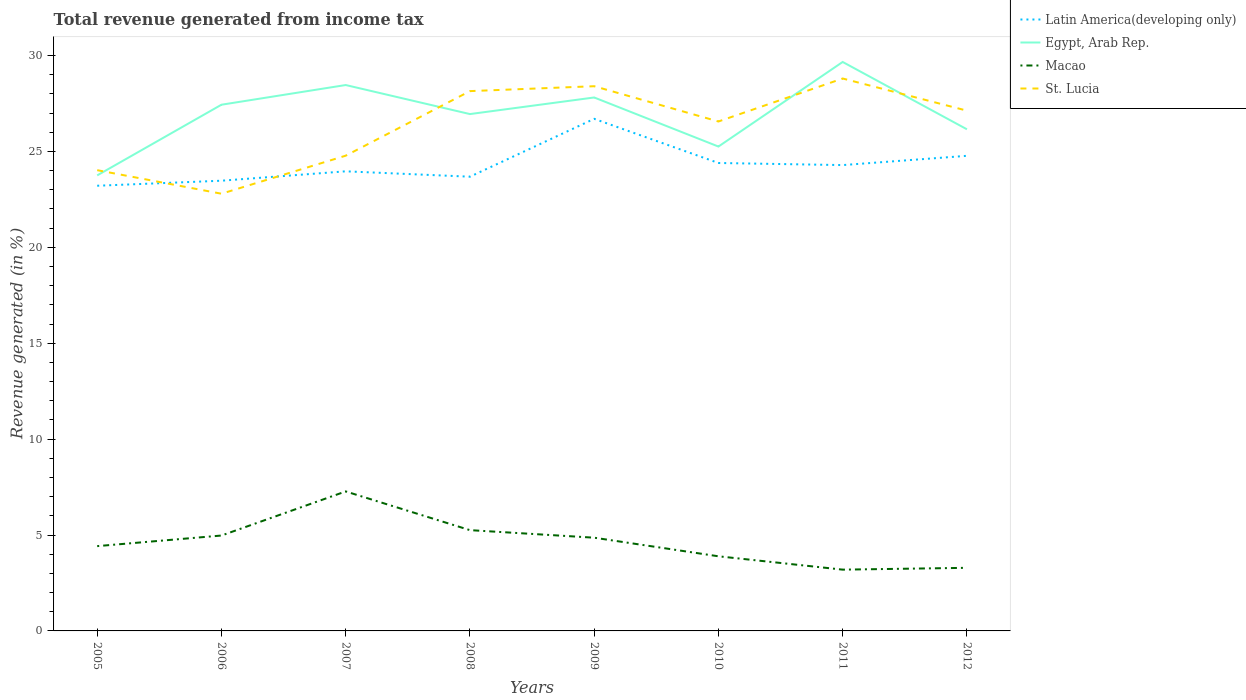How many different coloured lines are there?
Provide a short and direct response. 4. Does the line corresponding to Macao intersect with the line corresponding to Egypt, Arab Rep.?
Offer a very short reply. No. Is the number of lines equal to the number of legend labels?
Your response must be concise. Yes. Across all years, what is the maximum total revenue generated in Egypt, Arab Rep.?
Ensure brevity in your answer.  23.75. What is the total total revenue generated in St. Lucia in the graph?
Provide a short and direct response. 1.02. What is the difference between the highest and the second highest total revenue generated in Latin America(developing only)?
Offer a terse response. 3.49. What is the difference between the highest and the lowest total revenue generated in Latin America(developing only)?
Make the answer very short. 3. What is the difference between two consecutive major ticks on the Y-axis?
Ensure brevity in your answer.  5. Are the values on the major ticks of Y-axis written in scientific E-notation?
Make the answer very short. No. Does the graph contain any zero values?
Your answer should be very brief. No. How are the legend labels stacked?
Your response must be concise. Vertical. What is the title of the graph?
Offer a very short reply. Total revenue generated from income tax. What is the label or title of the Y-axis?
Your response must be concise. Revenue generated (in %). What is the Revenue generated (in %) in Latin America(developing only) in 2005?
Give a very brief answer. 23.21. What is the Revenue generated (in %) of Egypt, Arab Rep. in 2005?
Ensure brevity in your answer.  23.75. What is the Revenue generated (in %) in Macao in 2005?
Offer a very short reply. 4.42. What is the Revenue generated (in %) of St. Lucia in 2005?
Your answer should be very brief. 24.02. What is the Revenue generated (in %) of Latin America(developing only) in 2006?
Your answer should be very brief. 23.47. What is the Revenue generated (in %) in Egypt, Arab Rep. in 2006?
Offer a terse response. 27.44. What is the Revenue generated (in %) in Macao in 2006?
Your answer should be very brief. 4.97. What is the Revenue generated (in %) of St. Lucia in 2006?
Offer a very short reply. 22.8. What is the Revenue generated (in %) in Latin America(developing only) in 2007?
Your response must be concise. 23.96. What is the Revenue generated (in %) of Egypt, Arab Rep. in 2007?
Offer a terse response. 28.46. What is the Revenue generated (in %) in Macao in 2007?
Provide a succinct answer. 7.27. What is the Revenue generated (in %) of St. Lucia in 2007?
Give a very brief answer. 24.78. What is the Revenue generated (in %) in Latin America(developing only) in 2008?
Offer a terse response. 23.68. What is the Revenue generated (in %) in Egypt, Arab Rep. in 2008?
Keep it short and to the point. 26.95. What is the Revenue generated (in %) of Macao in 2008?
Make the answer very short. 5.25. What is the Revenue generated (in %) of St. Lucia in 2008?
Offer a terse response. 28.15. What is the Revenue generated (in %) of Latin America(developing only) in 2009?
Keep it short and to the point. 26.7. What is the Revenue generated (in %) of Egypt, Arab Rep. in 2009?
Offer a very short reply. 27.81. What is the Revenue generated (in %) in Macao in 2009?
Your answer should be compact. 4.86. What is the Revenue generated (in %) in St. Lucia in 2009?
Your answer should be very brief. 28.4. What is the Revenue generated (in %) of Latin America(developing only) in 2010?
Make the answer very short. 24.4. What is the Revenue generated (in %) in Egypt, Arab Rep. in 2010?
Provide a succinct answer. 25.26. What is the Revenue generated (in %) in Macao in 2010?
Make the answer very short. 3.89. What is the Revenue generated (in %) in St. Lucia in 2010?
Make the answer very short. 26.56. What is the Revenue generated (in %) in Latin America(developing only) in 2011?
Give a very brief answer. 24.29. What is the Revenue generated (in %) of Egypt, Arab Rep. in 2011?
Your answer should be very brief. 29.67. What is the Revenue generated (in %) of Macao in 2011?
Offer a terse response. 3.2. What is the Revenue generated (in %) in St. Lucia in 2011?
Ensure brevity in your answer.  28.8. What is the Revenue generated (in %) in Latin America(developing only) in 2012?
Your answer should be very brief. 24.77. What is the Revenue generated (in %) of Egypt, Arab Rep. in 2012?
Your response must be concise. 26.15. What is the Revenue generated (in %) of Macao in 2012?
Make the answer very short. 3.29. What is the Revenue generated (in %) in St. Lucia in 2012?
Your answer should be very brief. 27.13. Across all years, what is the maximum Revenue generated (in %) of Latin America(developing only)?
Give a very brief answer. 26.7. Across all years, what is the maximum Revenue generated (in %) of Egypt, Arab Rep.?
Offer a terse response. 29.67. Across all years, what is the maximum Revenue generated (in %) in Macao?
Your response must be concise. 7.27. Across all years, what is the maximum Revenue generated (in %) in St. Lucia?
Keep it short and to the point. 28.8. Across all years, what is the minimum Revenue generated (in %) in Latin America(developing only)?
Ensure brevity in your answer.  23.21. Across all years, what is the minimum Revenue generated (in %) of Egypt, Arab Rep.?
Your response must be concise. 23.75. Across all years, what is the minimum Revenue generated (in %) of Macao?
Your answer should be compact. 3.2. Across all years, what is the minimum Revenue generated (in %) in St. Lucia?
Keep it short and to the point. 22.8. What is the total Revenue generated (in %) of Latin America(developing only) in the graph?
Provide a succinct answer. 194.49. What is the total Revenue generated (in %) of Egypt, Arab Rep. in the graph?
Offer a terse response. 215.49. What is the total Revenue generated (in %) of Macao in the graph?
Keep it short and to the point. 37.16. What is the total Revenue generated (in %) of St. Lucia in the graph?
Your response must be concise. 210.64. What is the difference between the Revenue generated (in %) in Latin America(developing only) in 2005 and that in 2006?
Your answer should be compact. -0.26. What is the difference between the Revenue generated (in %) in Egypt, Arab Rep. in 2005 and that in 2006?
Your answer should be very brief. -3.68. What is the difference between the Revenue generated (in %) of Macao in 2005 and that in 2006?
Your response must be concise. -0.55. What is the difference between the Revenue generated (in %) of St. Lucia in 2005 and that in 2006?
Provide a succinct answer. 1.23. What is the difference between the Revenue generated (in %) in Latin America(developing only) in 2005 and that in 2007?
Provide a succinct answer. -0.75. What is the difference between the Revenue generated (in %) of Egypt, Arab Rep. in 2005 and that in 2007?
Offer a terse response. -4.71. What is the difference between the Revenue generated (in %) of Macao in 2005 and that in 2007?
Keep it short and to the point. -2.85. What is the difference between the Revenue generated (in %) in St. Lucia in 2005 and that in 2007?
Give a very brief answer. -0.76. What is the difference between the Revenue generated (in %) in Latin America(developing only) in 2005 and that in 2008?
Your answer should be very brief. -0.47. What is the difference between the Revenue generated (in %) of Egypt, Arab Rep. in 2005 and that in 2008?
Your answer should be compact. -3.2. What is the difference between the Revenue generated (in %) of Macao in 2005 and that in 2008?
Provide a short and direct response. -0.83. What is the difference between the Revenue generated (in %) in St. Lucia in 2005 and that in 2008?
Offer a terse response. -4.12. What is the difference between the Revenue generated (in %) of Latin America(developing only) in 2005 and that in 2009?
Offer a very short reply. -3.49. What is the difference between the Revenue generated (in %) in Egypt, Arab Rep. in 2005 and that in 2009?
Your answer should be very brief. -4.06. What is the difference between the Revenue generated (in %) in Macao in 2005 and that in 2009?
Give a very brief answer. -0.44. What is the difference between the Revenue generated (in %) in St. Lucia in 2005 and that in 2009?
Keep it short and to the point. -4.38. What is the difference between the Revenue generated (in %) in Latin America(developing only) in 2005 and that in 2010?
Give a very brief answer. -1.19. What is the difference between the Revenue generated (in %) of Egypt, Arab Rep. in 2005 and that in 2010?
Ensure brevity in your answer.  -1.5. What is the difference between the Revenue generated (in %) of Macao in 2005 and that in 2010?
Provide a short and direct response. 0.53. What is the difference between the Revenue generated (in %) in St. Lucia in 2005 and that in 2010?
Your response must be concise. -2.54. What is the difference between the Revenue generated (in %) of Latin America(developing only) in 2005 and that in 2011?
Your answer should be very brief. -1.08. What is the difference between the Revenue generated (in %) of Egypt, Arab Rep. in 2005 and that in 2011?
Keep it short and to the point. -5.91. What is the difference between the Revenue generated (in %) in Macao in 2005 and that in 2011?
Your answer should be compact. 1.23. What is the difference between the Revenue generated (in %) of St. Lucia in 2005 and that in 2011?
Provide a succinct answer. -4.78. What is the difference between the Revenue generated (in %) of Latin America(developing only) in 2005 and that in 2012?
Offer a very short reply. -1.56. What is the difference between the Revenue generated (in %) in Egypt, Arab Rep. in 2005 and that in 2012?
Your answer should be compact. -2.4. What is the difference between the Revenue generated (in %) of Macao in 2005 and that in 2012?
Your answer should be compact. 1.13. What is the difference between the Revenue generated (in %) of St. Lucia in 2005 and that in 2012?
Your answer should be compact. -3.1. What is the difference between the Revenue generated (in %) of Latin America(developing only) in 2006 and that in 2007?
Provide a succinct answer. -0.49. What is the difference between the Revenue generated (in %) in Egypt, Arab Rep. in 2006 and that in 2007?
Make the answer very short. -1.03. What is the difference between the Revenue generated (in %) in Macao in 2006 and that in 2007?
Ensure brevity in your answer.  -2.3. What is the difference between the Revenue generated (in %) of St. Lucia in 2006 and that in 2007?
Make the answer very short. -1.98. What is the difference between the Revenue generated (in %) of Latin America(developing only) in 2006 and that in 2008?
Offer a terse response. -0.21. What is the difference between the Revenue generated (in %) of Egypt, Arab Rep. in 2006 and that in 2008?
Your answer should be compact. 0.49. What is the difference between the Revenue generated (in %) in Macao in 2006 and that in 2008?
Ensure brevity in your answer.  -0.28. What is the difference between the Revenue generated (in %) of St. Lucia in 2006 and that in 2008?
Provide a short and direct response. -5.35. What is the difference between the Revenue generated (in %) of Latin America(developing only) in 2006 and that in 2009?
Keep it short and to the point. -3.23. What is the difference between the Revenue generated (in %) in Egypt, Arab Rep. in 2006 and that in 2009?
Make the answer very short. -0.38. What is the difference between the Revenue generated (in %) in Macao in 2006 and that in 2009?
Provide a succinct answer. 0.11. What is the difference between the Revenue generated (in %) in St. Lucia in 2006 and that in 2009?
Offer a terse response. -5.61. What is the difference between the Revenue generated (in %) of Latin America(developing only) in 2006 and that in 2010?
Your answer should be very brief. -0.92. What is the difference between the Revenue generated (in %) of Egypt, Arab Rep. in 2006 and that in 2010?
Ensure brevity in your answer.  2.18. What is the difference between the Revenue generated (in %) of Macao in 2006 and that in 2010?
Offer a terse response. 1.08. What is the difference between the Revenue generated (in %) of St. Lucia in 2006 and that in 2010?
Ensure brevity in your answer.  -3.77. What is the difference between the Revenue generated (in %) in Latin America(developing only) in 2006 and that in 2011?
Provide a succinct answer. -0.81. What is the difference between the Revenue generated (in %) of Egypt, Arab Rep. in 2006 and that in 2011?
Provide a short and direct response. -2.23. What is the difference between the Revenue generated (in %) in Macao in 2006 and that in 2011?
Offer a terse response. 1.78. What is the difference between the Revenue generated (in %) of St. Lucia in 2006 and that in 2011?
Make the answer very short. -6.01. What is the difference between the Revenue generated (in %) in Latin America(developing only) in 2006 and that in 2012?
Provide a short and direct response. -1.3. What is the difference between the Revenue generated (in %) in Egypt, Arab Rep. in 2006 and that in 2012?
Provide a short and direct response. 1.28. What is the difference between the Revenue generated (in %) in Macao in 2006 and that in 2012?
Your answer should be compact. 1.68. What is the difference between the Revenue generated (in %) of St. Lucia in 2006 and that in 2012?
Provide a short and direct response. -4.33. What is the difference between the Revenue generated (in %) of Latin America(developing only) in 2007 and that in 2008?
Offer a very short reply. 0.28. What is the difference between the Revenue generated (in %) of Egypt, Arab Rep. in 2007 and that in 2008?
Ensure brevity in your answer.  1.51. What is the difference between the Revenue generated (in %) of Macao in 2007 and that in 2008?
Provide a short and direct response. 2.02. What is the difference between the Revenue generated (in %) in St. Lucia in 2007 and that in 2008?
Your answer should be compact. -3.37. What is the difference between the Revenue generated (in %) of Latin America(developing only) in 2007 and that in 2009?
Provide a short and direct response. -2.74. What is the difference between the Revenue generated (in %) of Egypt, Arab Rep. in 2007 and that in 2009?
Provide a succinct answer. 0.65. What is the difference between the Revenue generated (in %) of Macao in 2007 and that in 2009?
Provide a short and direct response. 2.41. What is the difference between the Revenue generated (in %) in St. Lucia in 2007 and that in 2009?
Offer a very short reply. -3.62. What is the difference between the Revenue generated (in %) in Latin America(developing only) in 2007 and that in 2010?
Your answer should be compact. -0.43. What is the difference between the Revenue generated (in %) of Egypt, Arab Rep. in 2007 and that in 2010?
Make the answer very short. 3.21. What is the difference between the Revenue generated (in %) of Macao in 2007 and that in 2010?
Your response must be concise. 3.38. What is the difference between the Revenue generated (in %) of St. Lucia in 2007 and that in 2010?
Your answer should be compact. -1.78. What is the difference between the Revenue generated (in %) of Latin America(developing only) in 2007 and that in 2011?
Keep it short and to the point. -0.33. What is the difference between the Revenue generated (in %) in Egypt, Arab Rep. in 2007 and that in 2011?
Your response must be concise. -1.2. What is the difference between the Revenue generated (in %) in Macao in 2007 and that in 2011?
Your response must be concise. 4.08. What is the difference between the Revenue generated (in %) of St. Lucia in 2007 and that in 2011?
Offer a very short reply. -4.02. What is the difference between the Revenue generated (in %) of Latin America(developing only) in 2007 and that in 2012?
Give a very brief answer. -0.81. What is the difference between the Revenue generated (in %) in Egypt, Arab Rep. in 2007 and that in 2012?
Make the answer very short. 2.31. What is the difference between the Revenue generated (in %) in Macao in 2007 and that in 2012?
Offer a very short reply. 3.98. What is the difference between the Revenue generated (in %) in St. Lucia in 2007 and that in 2012?
Offer a very short reply. -2.35. What is the difference between the Revenue generated (in %) of Latin America(developing only) in 2008 and that in 2009?
Your response must be concise. -3.02. What is the difference between the Revenue generated (in %) of Egypt, Arab Rep. in 2008 and that in 2009?
Your response must be concise. -0.86. What is the difference between the Revenue generated (in %) in Macao in 2008 and that in 2009?
Provide a short and direct response. 0.39. What is the difference between the Revenue generated (in %) of St. Lucia in 2008 and that in 2009?
Offer a terse response. -0.26. What is the difference between the Revenue generated (in %) in Latin America(developing only) in 2008 and that in 2010?
Your response must be concise. -0.72. What is the difference between the Revenue generated (in %) of Egypt, Arab Rep. in 2008 and that in 2010?
Keep it short and to the point. 1.69. What is the difference between the Revenue generated (in %) of Macao in 2008 and that in 2010?
Keep it short and to the point. 1.36. What is the difference between the Revenue generated (in %) in St. Lucia in 2008 and that in 2010?
Make the answer very short. 1.58. What is the difference between the Revenue generated (in %) of Latin America(developing only) in 2008 and that in 2011?
Keep it short and to the point. -0.61. What is the difference between the Revenue generated (in %) of Egypt, Arab Rep. in 2008 and that in 2011?
Make the answer very short. -2.72. What is the difference between the Revenue generated (in %) in Macao in 2008 and that in 2011?
Offer a terse response. 2.06. What is the difference between the Revenue generated (in %) in St. Lucia in 2008 and that in 2011?
Make the answer very short. -0.66. What is the difference between the Revenue generated (in %) of Latin America(developing only) in 2008 and that in 2012?
Give a very brief answer. -1.09. What is the difference between the Revenue generated (in %) in Egypt, Arab Rep. in 2008 and that in 2012?
Make the answer very short. 0.79. What is the difference between the Revenue generated (in %) in Macao in 2008 and that in 2012?
Your answer should be compact. 1.96. What is the difference between the Revenue generated (in %) of St. Lucia in 2008 and that in 2012?
Keep it short and to the point. 1.02. What is the difference between the Revenue generated (in %) of Latin America(developing only) in 2009 and that in 2010?
Make the answer very short. 2.3. What is the difference between the Revenue generated (in %) in Egypt, Arab Rep. in 2009 and that in 2010?
Provide a short and direct response. 2.56. What is the difference between the Revenue generated (in %) in Macao in 2009 and that in 2010?
Ensure brevity in your answer.  0.97. What is the difference between the Revenue generated (in %) in St. Lucia in 2009 and that in 2010?
Your response must be concise. 1.84. What is the difference between the Revenue generated (in %) in Latin America(developing only) in 2009 and that in 2011?
Provide a succinct answer. 2.41. What is the difference between the Revenue generated (in %) in Egypt, Arab Rep. in 2009 and that in 2011?
Keep it short and to the point. -1.85. What is the difference between the Revenue generated (in %) of Macao in 2009 and that in 2011?
Make the answer very short. 1.67. What is the difference between the Revenue generated (in %) of St. Lucia in 2009 and that in 2011?
Offer a very short reply. -0.4. What is the difference between the Revenue generated (in %) in Latin America(developing only) in 2009 and that in 2012?
Ensure brevity in your answer.  1.93. What is the difference between the Revenue generated (in %) of Egypt, Arab Rep. in 2009 and that in 2012?
Offer a very short reply. 1.66. What is the difference between the Revenue generated (in %) in Macao in 2009 and that in 2012?
Offer a very short reply. 1.57. What is the difference between the Revenue generated (in %) in St. Lucia in 2009 and that in 2012?
Your response must be concise. 1.27. What is the difference between the Revenue generated (in %) in Latin America(developing only) in 2010 and that in 2011?
Give a very brief answer. 0.11. What is the difference between the Revenue generated (in %) of Egypt, Arab Rep. in 2010 and that in 2011?
Make the answer very short. -4.41. What is the difference between the Revenue generated (in %) in Macao in 2010 and that in 2011?
Offer a terse response. 0.7. What is the difference between the Revenue generated (in %) in St. Lucia in 2010 and that in 2011?
Offer a very short reply. -2.24. What is the difference between the Revenue generated (in %) of Latin America(developing only) in 2010 and that in 2012?
Make the answer very short. -0.37. What is the difference between the Revenue generated (in %) of Egypt, Arab Rep. in 2010 and that in 2012?
Give a very brief answer. -0.9. What is the difference between the Revenue generated (in %) of Macao in 2010 and that in 2012?
Your answer should be very brief. 0.6. What is the difference between the Revenue generated (in %) in St. Lucia in 2010 and that in 2012?
Make the answer very short. -0.56. What is the difference between the Revenue generated (in %) in Latin America(developing only) in 2011 and that in 2012?
Give a very brief answer. -0.48. What is the difference between the Revenue generated (in %) in Egypt, Arab Rep. in 2011 and that in 2012?
Provide a short and direct response. 3.51. What is the difference between the Revenue generated (in %) of Macao in 2011 and that in 2012?
Provide a succinct answer. -0.09. What is the difference between the Revenue generated (in %) of St. Lucia in 2011 and that in 2012?
Make the answer very short. 1.68. What is the difference between the Revenue generated (in %) of Latin America(developing only) in 2005 and the Revenue generated (in %) of Egypt, Arab Rep. in 2006?
Give a very brief answer. -4.22. What is the difference between the Revenue generated (in %) in Latin America(developing only) in 2005 and the Revenue generated (in %) in Macao in 2006?
Offer a terse response. 18.24. What is the difference between the Revenue generated (in %) of Latin America(developing only) in 2005 and the Revenue generated (in %) of St. Lucia in 2006?
Your response must be concise. 0.42. What is the difference between the Revenue generated (in %) in Egypt, Arab Rep. in 2005 and the Revenue generated (in %) in Macao in 2006?
Make the answer very short. 18.78. What is the difference between the Revenue generated (in %) in Egypt, Arab Rep. in 2005 and the Revenue generated (in %) in St. Lucia in 2006?
Make the answer very short. 0.96. What is the difference between the Revenue generated (in %) of Macao in 2005 and the Revenue generated (in %) of St. Lucia in 2006?
Your answer should be very brief. -18.37. What is the difference between the Revenue generated (in %) in Latin America(developing only) in 2005 and the Revenue generated (in %) in Egypt, Arab Rep. in 2007?
Your answer should be compact. -5.25. What is the difference between the Revenue generated (in %) of Latin America(developing only) in 2005 and the Revenue generated (in %) of Macao in 2007?
Your answer should be compact. 15.94. What is the difference between the Revenue generated (in %) in Latin America(developing only) in 2005 and the Revenue generated (in %) in St. Lucia in 2007?
Give a very brief answer. -1.57. What is the difference between the Revenue generated (in %) of Egypt, Arab Rep. in 2005 and the Revenue generated (in %) of Macao in 2007?
Provide a succinct answer. 16.48. What is the difference between the Revenue generated (in %) of Egypt, Arab Rep. in 2005 and the Revenue generated (in %) of St. Lucia in 2007?
Provide a succinct answer. -1.03. What is the difference between the Revenue generated (in %) of Macao in 2005 and the Revenue generated (in %) of St. Lucia in 2007?
Keep it short and to the point. -20.36. What is the difference between the Revenue generated (in %) of Latin America(developing only) in 2005 and the Revenue generated (in %) of Egypt, Arab Rep. in 2008?
Give a very brief answer. -3.74. What is the difference between the Revenue generated (in %) of Latin America(developing only) in 2005 and the Revenue generated (in %) of Macao in 2008?
Your answer should be very brief. 17.96. What is the difference between the Revenue generated (in %) in Latin America(developing only) in 2005 and the Revenue generated (in %) in St. Lucia in 2008?
Ensure brevity in your answer.  -4.93. What is the difference between the Revenue generated (in %) in Egypt, Arab Rep. in 2005 and the Revenue generated (in %) in Macao in 2008?
Ensure brevity in your answer.  18.5. What is the difference between the Revenue generated (in %) in Egypt, Arab Rep. in 2005 and the Revenue generated (in %) in St. Lucia in 2008?
Offer a very short reply. -4.39. What is the difference between the Revenue generated (in %) in Macao in 2005 and the Revenue generated (in %) in St. Lucia in 2008?
Ensure brevity in your answer.  -23.72. What is the difference between the Revenue generated (in %) of Latin America(developing only) in 2005 and the Revenue generated (in %) of Egypt, Arab Rep. in 2009?
Provide a short and direct response. -4.6. What is the difference between the Revenue generated (in %) in Latin America(developing only) in 2005 and the Revenue generated (in %) in Macao in 2009?
Give a very brief answer. 18.35. What is the difference between the Revenue generated (in %) in Latin America(developing only) in 2005 and the Revenue generated (in %) in St. Lucia in 2009?
Provide a succinct answer. -5.19. What is the difference between the Revenue generated (in %) in Egypt, Arab Rep. in 2005 and the Revenue generated (in %) in Macao in 2009?
Provide a succinct answer. 18.89. What is the difference between the Revenue generated (in %) of Egypt, Arab Rep. in 2005 and the Revenue generated (in %) of St. Lucia in 2009?
Provide a short and direct response. -4.65. What is the difference between the Revenue generated (in %) of Macao in 2005 and the Revenue generated (in %) of St. Lucia in 2009?
Your response must be concise. -23.98. What is the difference between the Revenue generated (in %) of Latin America(developing only) in 2005 and the Revenue generated (in %) of Egypt, Arab Rep. in 2010?
Offer a terse response. -2.04. What is the difference between the Revenue generated (in %) in Latin America(developing only) in 2005 and the Revenue generated (in %) in Macao in 2010?
Keep it short and to the point. 19.32. What is the difference between the Revenue generated (in %) of Latin America(developing only) in 2005 and the Revenue generated (in %) of St. Lucia in 2010?
Provide a succinct answer. -3.35. What is the difference between the Revenue generated (in %) in Egypt, Arab Rep. in 2005 and the Revenue generated (in %) in Macao in 2010?
Make the answer very short. 19.86. What is the difference between the Revenue generated (in %) in Egypt, Arab Rep. in 2005 and the Revenue generated (in %) in St. Lucia in 2010?
Ensure brevity in your answer.  -2.81. What is the difference between the Revenue generated (in %) in Macao in 2005 and the Revenue generated (in %) in St. Lucia in 2010?
Your response must be concise. -22.14. What is the difference between the Revenue generated (in %) of Latin America(developing only) in 2005 and the Revenue generated (in %) of Egypt, Arab Rep. in 2011?
Your answer should be compact. -6.45. What is the difference between the Revenue generated (in %) of Latin America(developing only) in 2005 and the Revenue generated (in %) of Macao in 2011?
Provide a short and direct response. 20.02. What is the difference between the Revenue generated (in %) of Latin America(developing only) in 2005 and the Revenue generated (in %) of St. Lucia in 2011?
Give a very brief answer. -5.59. What is the difference between the Revenue generated (in %) of Egypt, Arab Rep. in 2005 and the Revenue generated (in %) of Macao in 2011?
Your response must be concise. 20.56. What is the difference between the Revenue generated (in %) in Egypt, Arab Rep. in 2005 and the Revenue generated (in %) in St. Lucia in 2011?
Your answer should be very brief. -5.05. What is the difference between the Revenue generated (in %) of Macao in 2005 and the Revenue generated (in %) of St. Lucia in 2011?
Give a very brief answer. -24.38. What is the difference between the Revenue generated (in %) in Latin America(developing only) in 2005 and the Revenue generated (in %) in Egypt, Arab Rep. in 2012?
Your answer should be very brief. -2.94. What is the difference between the Revenue generated (in %) in Latin America(developing only) in 2005 and the Revenue generated (in %) in Macao in 2012?
Make the answer very short. 19.92. What is the difference between the Revenue generated (in %) of Latin America(developing only) in 2005 and the Revenue generated (in %) of St. Lucia in 2012?
Provide a short and direct response. -3.91. What is the difference between the Revenue generated (in %) in Egypt, Arab Rep. in 2005 and the Revenue generated (in %) in Macao in 2012?
Keep it short and to the point. 20.46. What is the difference between the Revenue generated (in %) of Egypt, Arab Rep. in 2005 and the Revenue generated (in %) of St. Lucia in 2012?
Provide a succinct answer. -3.38. What is the difference between the Revenue generated (in %) of Macao in 2005 and the Revenue generated (in %) of St. Lucia in 2012?
Keep it short and to the point. -22.71. What is the difference between the Revenue generated (in %) of Latin America(developing only) in 2006 and the Revenue generated (in %) of Egypt, Arab Rep. in 2007?
Make the answer very short. -4.99. What is the difference between the Revenue generated (in %) of Latin America(developing only) in 2006 and the Revenue generated (in %) of Macao in 2007?
Give a very brief answer. 16.2. What is the difference between the Revenue generated (in %) of Latin America(developing only) in 2006 and the Revenue generated (in %) of St. Lucia in 2007?
Offer a terse response. -1.3. What is the difference between the Revenue generated (in %) in Egypt, Arab Rep. in 2006 and the Revenue generated (in %) in Macao in 2007?
Provide a short and direct response. 20.16. What is the difference between the Revenue generated (in %) of Egypt, Arab Rep. in 2006 and the Revenue generated (in %) of St. Lucia in 2007?
Keep it short and to the point. 2.66. What is the difference between the Revenue generated (in %) in Macao in 2006 and the Revenue generated (in %) in St. Lucia in 2007?
Offer a terse response. -19.81. What is the difference between the Revenue generated (in %) of Latin America(developing only) in 2006 and the Revenue generated (in %) of Egypt, Arab Rep. in 2008?
Make the answer very short. -3.47. What is the difference between the Revenue generated (in %) of Latin America(developing only) in 2006 and the Revenue generated (in %) of Macao in 2008?
Provide a succinct answer. 18.22. What is the difference between the Revenue generated (in %) of Latin America(developing only) in 2006 and the Revenue generated (in %) of St. Lucia in 2008?
Offer a very short reply. -4.67. What is the difference between the Revenue generated (in %) in Egypt, Arab Rep. in 2006 and the Revenue generated (in %) in Macao in 2008?
Provide a succinct answer. 22.18. What is the difference between the Revenue generated (in %) of Egypt, Arab Rep. in 2006 and the Revenue generated (in %) of St. Lucia in 2008?
Your answer should be very brief. -0.71. What is the difference between the Revenue generated (in %) in Macao in 2006 and the Revenue generated (in %) in St. Lucia in 2008?
Ensure brevity in your answer.  -23.17. What is the difference between the Revenue generated (in %) of Latin America(developing only) in 2006 and the Revenue generated (in %) of Egypt, Arab Rep. in 2009?
Provide a succinct answer. -4.34. What is the difference between the Revenue generated (in %) in Latin America(developing only) in 2006 and the Revenue generated (in %) in Macao in 2009?
Offer a very short reply. 18.61. What is the difference between the Revenue generated (in %) in Latin America(developing only) in 2006 and the Revenue generated (in %) in St. Lucia in 2009?
Keep it short and to the point. -4.93. What is the difference between the Revenue generated (in %) of Egypt, Arab Rep. in 2006 and the Revenue generated (in %) of Macao in 2009?
Offer a very short reply. 22.58. What is the difference between the Revenue generated (in %) in Egypt, Arab Rep. in 2006 and the Revenue generated (in %) in St. Lucia in 2009?
Offer a very short reply. -0.96. What is the difference between the Revenue generated (in %) in Macao in 2006 and the Revenue generated (in %) in St. Lucia in 2009?
Provide a short and direct response. -23.43. What is the difference between the Revenue generated (in %) of Latin America(developing only) in 2006 and the Revenue generated (in %) of Egypt, Arab Rep. in 2010?
Provide a succinct answer. -1.78. What is the difference between the Revenue generated (in %) in Latin America(developing only) in 2006 and the Revenue generated (in %) in Macao in 2010?
Make the answer very short. 19.58. What is the difference between the Revenue generated (in %) in Latin America(developing only) in 2006 and the Revenue generated (in %) in St. Lucia in 2010?
Ensure brevity in your answer.  -3.09. What is the difference between the Revenue generated (in %) in Egypt, Arab Rep. in 2006 and the Revenue generated (in %) in Macao in 2010?
Offer a terse response. 23.54. What is the difference between the Revenue generated (in %) of Egypt, Arab Rep. in 2006 and the Revenue generated (in %) of St. Lucia in 2010?
Offer a terse response. 0.87. What is the difference between the Revenue generated (in %) of Macao in 2006 and the Revenue generated (in %) of St. Lucia in 2010?
Give a very brief answer. -21.59. What is the difference between the Revenue generated (in %) in Latin America(developing only) in 2006 and the Revenue generated (in %) in Egypt, Arab Rep. in 2011?
Offer a very short reply. -6.19. What is the difference between the Revenue generated (in %) in Latin America(developing only) in 2006 and the Revenue generated (in %) in Macao in 2011?
Offer a terse response. 20.28. What is the difference between the Revenue generated (in %) in Latin America(developing only) in 2006 and the Revenue generated (in %) in St. Lucia in 2011?
Provide a succinct answer. -5.33. What is the difference between the Revenue generated (in %) of Egypt, Arab Rep. in 2006 and the Revenue generated (in %) of Macao in 2011?
Offer a terse response. 24.24. What is the difference between the Revenue generated (in %) of Egypt, Arab Rep. in 2006 and the Revenue generated (in %) of St. Lucia in 2011?
Your answer should be compact. -1.37. What is the difference between the Revenue generated (in %) in Macao in 2006 and the Revenue generated (in %) in St. Lucia in 2011?
Your answer should be compact. -23.83. What is the difference between the Revenue generated (in %) of Latin America(developing only) in 2006 and the Revenue generated (in %) of Egypt, Arab Rep. in 2012?
Offer a terse response. -2.68. What is the difference between the Revenue generated (in %) in Latin America(developing only) in 2006 and the Revenue generated (in %) in Macao in 2012?
Your answer should be compact. 20.18. What is the difference between the Revenue generated (in %) of Latin America(developing only) in 2006 and the Revenue generated (in %) of St. Lucia in 2012?
Provide a succinct answer. -3.65. What is the difference between the Revenue generated (in %) in Egypt, Arab Rep. in 2006 and the Revenue generated (in %) in Macao in 2012?
Your response must be concise. 24.15. What is the difference between the Revenue generated (in %) of Egypt, Arab Rep. in 2006 and the Revenue generated (in %) of St. Lucia in 2012?
Provide a succinct answer. 0.31. What is the difference between the Revenue generated (in %) of Macao in 2006 and the Revenue generated (in %) of St. Lucia in 2012?
Your answer should be compact. -22.15. What is the difference between the Revenue generated (in %) in Latin America(developing only) in 2007 and the Revenue generated (in %) in Egypt, Arab Rep. in 2008?
Make the answer very short. -2.98. What is the difference between the Revenue generated (in %) in Latin America(developing only) in 2007 and the Revenue generated (in %) in Macao in 2008?
Give a very brief answer. 18.71. What is the difference between the Revenue generated (in %) of Latin America(developing only) in 2007 and the Revenue generated (in %) of St. Lucia in 2008?
Offer a very short reply. -4.18. What is the difference between the Revenue generated (in %) in Egypt, Arab Rep. in 2007 and the Revenue generated (in %) in Macao in 2008?
Provide a short and direct response. 23.21. What is the difference between the Revenue generated (in %) in Egypt, Arab Rep. in 2007 and the Revenue generated (in %) in St. Lucia in 2008?
Keep it short and to the point. 0.32. What is the difference between the Revenue generated (in %) of Macao in 2007 and the Revenue generated (in %) of St. Lucia in 2008?
Provide a succinct answer. -20.87. What is the difference between the Revenue generated (in %) in Latin America(developing only) in 2007 and the Revenue generated (in %) in Egypt, Arab Rep. in 2009?
Your response must be concise. -3.85. What is the difference between the Revenue generated (in %) in Latin America(developing only) in 2007 and the Revenue generated (in %) in Macao in 2009?
Provide a short and direct response. 19.1. What is the difference between the Revenue generated (in %) of Latin America(developing only) in 2007 and the Revenue generated (in %) of St. Lucia in 2009?
Your answer should be very brief. -4.44. What is the difference between the Revenue generated (in %) in Egypt, Arab Rep. in 2007 and the Revenue generated (in %) in Macao in 2009?
Keep it short and to the point. 23.6. What is the difference between the Revenue generated (in %) of Egypt, Arab Rep. in 2007 and the Revenue generated (in %) of St. Lucia in 2009?
Offer a terse response. 0.06. What is the difference between the Revenue generated (in %) of Macao in 2007 and the Revenue generated (in %) of St. Lucia in 2009?
Make the answer very short. -21.13. What is the difference between the Revenue generated (in %) of Latin America(developing only) in 2007 and the Revenue generated (in %) of Egypt, Arab Rep. in 2010?
Provide a short and direct response. -1.29. What is the difference between the Revenue generated (in %) of Latin America(developing only) in 2007 and the Revenue generated (in %) of Macao in 2010?
Your answer should be very brief. 20.07. What is the difference between the Revenue generated (in %) of Latin America(developing only) in 2007 and the Revenue generated (in %) of St. Lucia in 2010?
Your answer should be compact. -2.6. What is the difference between the Revenue generated (in %) of Egypt, Arab Rep. in 2007 and the Revenue generated (in %) of Macao in 2010?
Offer a very short reply. 24.57. What is the difference between the Revenue generated (in %) in Egypt, Arab Rep. in 2007 and the Revenue generated (in %) in St. Lucia in 2010?
Make the answer very short. 1.9. What is the difference between the Revenue generated (in %) in Macao in 2007 and the Revenue generated (in %) in St. Lucia in 2010?
Provide a short and direct response. -19.29. What is the difference between the Revenue generated (in %) of Latin America(developing only) in 2007 and the Revenue generated (in %) of Egypt, Arab Rep. in 2011?
Offer a terse response. -5.7. What is the difference between the Revenue generated (in %) in Latin America(developing only) in 2007 and the Revenue generated (in %) in Macao in 2011?
Give a very brief answer. 20.77. What is the difference between the Revenue generated (in %) of Latin America(developing only) in 2007 and the Revenue generated (in %) of St. Lucia in 2011?
Keep it short and to the point. -4.84. What is the difference between the Revenue generated (in %) of Egypt, Arab Rep. in 2007 and the Revenue generated (in %) of Macao in 2011?
Give a very brief answer. 25.27. What is the difference between the Revenue generated (in %) of Egypt, Arab Rep. in 2007 and the Revenue generated (in %) of St. Lucia in 2011?
Your answer should be very brief. -0.34. What is the difference between the Revenue generated (in %) of Macao in 2007 and the Revenue generated (in %) of St. Lucia in 2011?
Your response must be concise. -21.53. What is the difference between the Revenue generated (in %) in Latin America(developing only) in 2007 and the Revenue generated (in %) in Egypt, Arab Rep. in 2012?
Make the answer very short. -2.19. What is the difference between the Revenue generated (in %) of Latin America(developing only) in 2007 and the Revenue generated (in %) of Macao in 2012?
Keep it short and to the point. 20.67. What is the difference between the Revenue generated (in %) of Latin America(developing only) in 2007 and the Revenue generated (in %) of St. Lucia in 2012?
Your answer should be compact. -3.16. What is the difference between the Revenue generated (in %) of Egypt, Arab Rep. in 2007 and the Revenue generated (in %) of Macao in 2012?
Keep it short and to the point. 25.17. What is the difference between the Revenue generated (in %) of Egypt, Arab Rep. in 2007 and the Revenue generated (in %) of St. Lucia in 2012?
Provide a succinct answer. 1.34. What is the difference between the Revenue generated (in %) in Macao in 2007 and the Revenue generated (in %) in St. Lucia in 2012?
Offer a very short reply. -19.85. What is the difference between the Revenue generated (in %) of Latin America(developing only) in 2008 and the Revenue generated (in %) of Egypt, Arab Rep. in 2009?
Offer a very short reply. -4.13. What is the difference between the Revenue generated (in %) of Latin America(developing only) in 2008 and the Revenue generated (in %) of Macao in 2009?
Offer a terse response. 18.82. What is the difference between the Revenue generated (in %) of Latin America(developing only) in 2008 and the Revenue generated (in %) of St. Lucia in 2009?
Provide a short and direct response. -4.72. What is the difference between the Revenue generated (in %) of Egypt, Arab Rep. in 2008 and the Revenue generated (in %) of Macao in 2009?
Give a very brief answer. 22.09. What is the difference between the Revenue generated (in %) of Egypt, Arab Rep. in 2008 and the Revenue generated (in %) of St. Lucia in 2009?
Your response must be concise. -1.45. What is the difference between the Revenue generated (in %) in Macao in 2008 and the Revenue generated (in %) in St. Lucia in 2009?
Offer a very short reply. -23.15. What is the difference between the Revenue generated (in %) of Latin America(developing only) in 2008 and the Revenue generated (in %) of Egypt, Arab Rep. in 2010?
Make the answer very short. -1.57. What is the difference between the Revenue generated (in %) in Latin America(developing only) in 2008 and the Revenue generated (in %) in Macao in 2010?
Keep it short and to the point. 19.79. What is the difference between the Revenue generated (in %) of Latin America(developing only) in 2008 and the Revenue generated (in %) of St. Lucia in 2010?
Provide a succinct answer. -2.88. What is the difference between the Revenue generated (in %) of Egypt, Arab Rep. in 2008 and the Revenue generated (in %) of Macao in 2010?
Ensure brevity in your answer.  23.06. What is the difference between the Revenue generated (in %) in Egypt, Arab Rep. in 2008 and the Revenue generated (in %) in St. Lucia in 2010?
Give a very brief answer. 0.39. What is the difference between the Revenue generated (in %) in Macao in 2008 and the Revenue generated (in %) in St. Lucia in 2010?
Your response must be concise. -21.31. What is the difference between the Revenue generated (in %) of Latin America(developing only) in 2008 and the Revenue generated (in %) of Egypt, Arab Rep. in 2011?
Keep it short and to the point. -5.98. What is the difference between the Revenue generated (in %) of Latin America(developing only) in 2008 and the Revenue generated (in %) of Macao in 2011?
Ensure brevity in your answer.  20.49. What is the difference between the Revenue generated (in %) of Latin America(developing only) in 2008 and the Revenue generated (in %) of St. Lucia in 2011?
Keep it short and to the point. -5.12. What is the difference between the Revenue generated (in %) of Egypt, Arab Rep. in 2008 and the Revenue generated (in %) of Macao in 2011?
Keep it short and to the point. 23.75. What is the difference between the Revenue generated (in %) of Egypt, Arab Rep. in 2008 and the Revenue generated (in %) of St. Lucia in 2011?
Offer a very short reply. -1.85. What is the difference between the Revenue generated (in %) of Macao in 2008 and the Revenue generated (in %) of St. Lucia in 2011?
Your response must be concise. -23.55. What is the difference between the Revenue generated (in %) of Latin America(developing only) in 2008 and the Revenue generated (in %) of Egypt, Arab Rep. in 2012?
Provide a short and direct response. -2.47. What is the difference between the Revenue generated (in %) in Latin America(developing only) in 2008 and the Revenue generated (in %) in Macao in 2012?
Your answer should be compact. 20.39. What is the difference between the Revenue generated (in %) in Latin America(developing only) in 2008 and the Revenue generated (in %) in St. Lucia in 2012?
Provide a succinct answer. -3.44. What is the difference between the Revenue generated (in %) of Egypt, Arab Rep. in 2008 and the Revenue generated (in %) of Macao in 2012?
Your answer should be compact. 23.66. What is the difference between the Revenue generated (in %) in Egypt, Arab Rep. in 2008 and the Revenue generated (in %) in St. Lucia in 2012?
Keep it short and to the point. -0.18. What is the difference between the Revenue generated (in %) in Macao in 2008 and the Revenue generated (in %) in St. Lucia in 2012?
Offer a terse response. -21.87. What is the difference between the Revenue generated (in %) in Latin America(developing only) in 2009 and the Revenue generated (in %) in Egypt, Arab Rep. in 2010?
Offer a terse response. 1.45. What is the difference between the Revenue generated (in %) of Latin America(developing only) in 2009 and the Revenue generated (in %) of Macao in 2010?
Keep it short and to the point. 22.81. What is the difference between the Revenue generated (in %) of Latin America(developing only) in 2009 and the Revenue generated (in %) of St. Lucia in 2010?
Your answer should be compact. 0.14. What is the difference between the Revenue generated (in %) of Egypt, Arab Rep. in 2009 and the Revenue generated (in %) of Macao in 2010?
Provide a short and direct response. 23.92. What is the difference between the Revenue generated (in %) in Egypt, Arab Rep. in 2009 and the Revenue generated (in %) in St. Lucia in 2010?
Provide a short and direct response. 1.25. What is the difference between the Revenue generated (in %) of Macao in 2009 and the Revenue generated (in %) of St. Lucia in 2010?
Your answer should be compact. -21.7. What is the difference between the Revenue generated (in %) of Latin America(developing only) in 2009 and the Revenue generated (in %) of Egypt, Arab Rep. in 2011?
Offer a very short reply. -2.97. What is the difference between the Revenue generated (in %) in Latin America(developing only) in 2009 and the Revenue generated (in %) in Macao in 2011?
Your answer should be very brief. 23.51. What is the difference between the Revenue generated (in %) of Latin America(developing only) in 2009 and the Revenue generated (in %) of St. Lucia in 2011?
Provide a short and direct response. -2.1. What is the difference between the Revenue generated (in %) in Egypt, Arab Rep. in 2009 and the Revenue generated (in %) in Macao in 2011?
Your answer should be compact. 24.62. What is the difference between the Revenue generated (in %) in Egypt, Arab Rep. in 2009 and the Revenue generated (in %) in St. Lucia in 2011?
Keep it short and to the point. -0.99. What is the difference between the Revenue generated (in %) of Macao in 2009 and the Revenue generated (in %) of St. Lucia in 2011?
Give a very brief answer. -23.94. What is the difference between the Revenue generated (in %) in Latin America(developing only) in 2009 and the Revenue generated (in %) in Egypt, Arab Rep. in 2012?
Give a very brief answer. 0.55. What is the difference between the Revenue generated (in %) of Latin America(developing only) in 2009 and the Revenue generated (in %) of Macao in 2012?
Make the answer very short. 23.41. What is the difference between the Revenue generated (in %) in Latin America(developing only) in 2009 and the Revenue generated (in %) in St. Lucia in 2012?
Ensure brevity in your answer.  -0.43. What is the difference between the Revenue generated (in %) of Egypt, Arab Rep. in 2009 and the Revenue generated (in %) of Macao in 2012?
Your response must be concise. 24.52. What is the difference between the Revenue generated (in %) in Egypt, Arab Rep. in 2009 and the Revenue generated (in %) in St. Lucia in 2012?
Give a very brief answer. 0.69. What is the difference between the Revenue generated (in %) of Macao in 2009 and the Revenue generated (in %) of St. Lucia in 2012?
Offer a very short reply. -22.27. What is the difference between the Revenue generated (in %) in Latin America(developing only) in 2010 and the Revenue generated (in %) in Egypt, Arab Rep. in 2011?
Your response must be concise. -5.27. What is the difference between the Revenue generated (in %) in Latin America(developing only) in 2010 and the Revenue generated (in %) in Macao in 2011?
Ensure brevity in your answer.  21.2. What is the difference between the Revenue generated (in %) of Latin America(developing only) in 2010 and the Revenue generated (in %) of St. Lucia in 2011?
Your response must be concise. -4.4. What is the difference between the Revenue generated (in %) of Egypt, Arab Rep. in 2010 and the Revenue generated (in %) of Macao in 2011?
Provide a short and direct response. 22.06. What is the difference between the Revenue generated (in %) in Egypt, Arab Rep. in 2010 and the Revenue generated (in %) in St. Lucia in 2011?
Your answer should be compact. -3.55. What is the difference between the Revenue generated (in %) of Macao in 2010 and the Revenue generated (in %) of St. Lucia in 2011?
Ensure brevity in your answer.  -24.91. What is the difference between the Revenue generated (in %) in Latin America(developing only) in 2010 and the Revenue generated (in %) in Egypt, Arab Rep. in 2012?
Provide a short and direct response. -1.76. What is the difference between the Revenue generated (in %) of Latin America(developing only) in 2010 and the Revenue generated (in %) of Macao in 2012?
Provide a short and direct response. 21.11. What is the difference between the Revenue generated (in %) in Latin America(developing only) in 2010 and the Revenue generated (in %) in St. Lucia in 2012?
Keep it short and to the point. -2.73. What is the difference between the Revenue generated (in %) in Egypt, Arab Rep. in 2010 and the Revenue generated (in %) in Macao in 2012?
Your answer should be compact. 21.97. What is the difference between the Revenue generated (in %) of Egypt, Arab Rep. in 2010 and the Revenue generated (in %) of St. Lucia in 2012?
Your response must be concise. -1.87. What is the difference between the Revenue generated (in %) in Macao in 2010 and the Revenue generated (in %) in St. Lucia in 2012?
Offer a terse response. -23.24. What is the difference between the Revenue generated (in %) in Latin America(developing only) in 2011 and the Revenue generated (in %) in Egypt, Arab Rep. in 2012?
Offer a terse response. -1.87. What is the difference between the Revenue generated (in %) of Latin America(developing only) in 2011 and the Revenue generated (in %) of Macao in 2012?
Provide a short and direct response. 21. What is the difference between the Revenue generated (in %) in Latin America(developing only) in 2011 and the Revenue generated (in %) in St. Lucia in 2012?
Offer a terse response. -2.84. What is the difference between the Revenue generated (in %) of Egypt, Arab Rep. in 2011 and the Revenue generated (in %) of Macao in 2012?
Offer a very short reply. 26.38. What is the difference between the Revenue generated (in %) of Egypt, Arab Rep. in 2011 and the Revenue generated (in %) of St. Lucia in 2012?
Your answer should be compact. 2.54. What is the difference between the Revenue generated (in %) in Macao in 2011 and the Revenue generated (in %) in St. Lucia in 2012?
Provide a succinct answer. -23.93. What is the average Revenue generated (in %) in Latin America(developing only) per year?
Provide a short and direct response. 24.31. What is the average Revenue generated (in %) in Egypt, Arab Rep. per year?
Give a very brief answer. 26.94. What is the average Revenue generated (in %) of Macao per year?
Make the answer very short. 4.64. What is the average Revenue generated (in %) in St. Lucia per year?
Make the answer very short. 26.33. In the year 2005, what is the difference between the Revenue generated (in %) in Latin America(developing only) and Revenue generated (in %) in Egypt, Arab Rep.?
Keep it short and to the point. -0.54. In the year 2005, what is the difference between the Revenue generated (in %) in Latin America(developing only) and Revenue generated (in %) in Macao?
Give a very brief answer. 18.79. In the year 2005, what is the difference between the Revenue generated (in %) in Latin America(developing only) and Revenue generated (in %) in St. Lucia?
Offer a terse response. -0.81. In the year 2005, what is the difference between the Revenue generated (in %) of Egypt, Arab Rep. and Revenue generated (in %) of Macao?
Ensure brevity in your answer.  19.33. In the year 2005, what is the difference between the Revenue generated (in %) of Egypt, Arab Rep. and Revenue generated (in %) of St. Lucia?
Your answer should be compact. -0.27. In the year 2005, what is the difference between the Revenue generated (in %) of Macao and Revenue generated (in %) of St. Lucia?
Offer a very short reply. -19.6. In the year 2006, what is the difference between the Revenue generated (in %) in Latin America(developing only) and Revenue generated (in %) in Egypt, Arab Rep.?
Keep it short and to the point. -3.96. In the year 2006, what is the difference between the Revenue generated (in %) in Latin America(developing only) and Revenue generated (in %) in Macao?
Provide a short and direct response. 18.5. In the year 2006, what is the difference between the Revenue generated (in %) in Latin America(developing only) and Revenue generated (in %) in St. Lucia?
Provide a short and direct response. 0.68. In the year 2006, what is the difference between the Revenue generated (in %) of Egypt, Arab Rep. and Revenue generated (in %) of Macao?
Provide a succinct answer. 22.46. In the year 2006, what is the difference between the Revenue generated (in %) of Egypt, Arab Rep. and Revenue generated (in %) of St. Lucia?
Your response must be concise. 4.64. In the year 2006, what is the difference between the Revenue generated (in %) of Macao and Revenue generated (in %) of St. Lucia?
Offer a terse response. -17.82. In the year 2007, what is the difference between the Revenue generated (in %) of Latin America(developing only) and Revenue generated (in %) of Egypt, Arab Rep.?
Offer a terse response. -4.5. In the year 2007, what is the difference between the Revenue generated (in %) in Latin America(developing only) and Revenue generated (in %) in Macao?
Ensure brevity in your answer.  16.69. In the year 2007, what is the difference between the Revenue generated (in %) in Latin America(developing only) and Revenue generated (in %) in St. Lucia?
Keep it short and to the point. -0.82. In the year 2007, what is the difference between the Revenue generated (in %) of Egypt, Arab Rep. and Revenue generated (in %) of Macao?
Keep it short and to the point. 21.19. In the year 2007, what is the difference between the Revenue generated (in %) in Egypt, Arab Rep. and Revenue generated (in %) in St. Lucia?
Give a very brief answer. 3.68. In the year 2007, what is the difference between the Revenue generated (in %) in Macao and Revenue generated (in %) in St. Lucia?
Provide a short and direct response. -17.51. In the year 2008, what is the difference between the Revenue generated (in %) in Latin America(developing only) and Revenue generated (in %) in Egypt, Arab Rep.?
Your response must be concise. -3.27. In the year 2008, what is the difference between the Revenue generated (in %) in Latin America(developing only) and Revenue generated (in %) in Macao?
Offer a very short reply. 18.43. In the year 2008, what is the difference between the Revenue generated (in %) of Latin America(developing only) and Revenue generated (in %) of St. Lucia?
Keep it short and to the point. -4.46. In the year 2008, what is the difference between the Revenue generated (in %) in Egypt, Arab Rep. and Revenue generated (in %) in Macao?
Your answer should be compact. 21.69. In the year 2008, what is the difference between the Revenue generated (in %) in Egypt, Arab Rep. and Revenue generated (in %) in St. Lucia?
Your answer should be compact. -1.2. In the year 2008, what is the difference between the Revenue generated (in %) in Macao and Revenue generated (in %) in St. Lucia?
Offer a terse response. -22.89. In the year 2009, what is the difference between the Revenue generated (in %) of Latin America(developing only) and Revenue generated (in %) of Egypt, Arab Rep.?
Offer a very short reply. -1.11. In the year 2009, what is the difference between the Revenue generated (in %) of Latin America(developing only) and Revenue generated (in %) of Macao?
Give a very brief answer. 21.84. In the year 2009, what is the difference between the Revenue generated (in %) of Latin America(developing only) and Revenue generated (in %) of St. Lucia?
Offer a terse response. -1.7. In the year 2009, what is the difference between the Revenue generated (in %) in Egypt, Arab Rep. and Revenue generated (in %) in Macao?
Make the answer very short. 22.95. In the year 2009, what is the difference between the Revenue generated (in %) in Egypt, Arab Rep. and Revenue generated (in %) in St. Lucia?
Provide a short and direct response. -0.59. In the year 2009, what is the difference between the Revenue generated (in %) of Macao and Revenue generated (in %) of St. Lucia?
Provide a succinct answer. -23.54. In the year 2010, what is the difference between the Revenue generated (in %) in Latin America(developing only) and Revenue generated (in %) in Egypt, Arab Rep.?
Offer a terse response. -0.86. In the year 2010, what is the difference between the Revenue generated (in %) of Latin America(developing only) and Revenue generated (in %) of Macao?
Keep it short and to the point. 20.51. In the year 2010, what is the difference between the Revenue generated (in %) of Latin America(developing only) and Revenue generated (in %) of St. Lucia?
Your response must be concise. -2.16. In the year 2010, what is the difference between the Revenue generated (in %) of Egypt, Arab Rep. and Revenue generated (in %) of Macao?
Offer a terse response. 21.36. In the year 2010, what is the difference between the Revenue generated (in %) in Egypt, Arab Rep. and Revenue generated (in %) in St. Lucia?
Make the answer very short. -1.31. In the year 2010, what is the difference between the Revenue generated (in %) in Macao and Revenue generated (in %) in St. Lucia?
Your answer should be very brief. -22.67. In the year 2011, what is the difference between the Revenue generated (in %) in Latin America(developing only) and Revenue generated (in %) in Egypt, Arab Rep.?
Your answer should be very brief. -5.38. In the year 2011, what is the difference between the Revenue generated (in %) of Latin America(developing only) and Revenue generated (in %) of Macao?
Provide a short and direct response. 21.09. In the year 2011, what is the difference between the Revenue generated (in %) of Latin America(developing only) and Revenue generated (in %) of St. Lucia?
Make the answer very short. -4.51. In the year 2011, what is the difference between the Revenue generated (in %) of Egypt, Arab Rep. and Revenue generated (in %) of Macao?
Your response must be concise. 26.47. In the year 2011, what is the difference between the Revenue generated (in %) of Egypt, Arab Rep. and Revenue generated (in %) of St. Lucia?
Your answer should be very brief. 0.86. In the year 2011, what is the difference between the Revenue generated (in %) of Macao and Revenue generated (in %) of St. Lucia?
Provide a short and direct response. -25.61. In the year 2012, what is the difference between the Revenue generated (in %) of Latin America(developing only) and Revenue generated (in %) of Egypt, Arab Rep.?
Make the answer very short. -1.38. In the year 2012, what is the difference between the Revenue generated (in %) in Latin America(developing only) and Revenue generated (in %) in Macao?
Give a very brief answer. 21.48. In the year 2012, what is the difference between the Revenue generated (in %) in Latin America(developing only) and Revenue generated (in %) in St. Lucia?
Keep it short and to the point. -2.35. In the year 2012, what is the difference between the Revenue generated (in %) in Egypt, Arab Rep. and Revenue generated (in %) in Macao?
Provide a short and direct response. 22.86. In the year 2012, what is the difference between the Revenue generated (in %) in Egypt, Arab Rep. and Revenue generated (in %) in St. Lucia?
Provide a short and direct response. -0.97. In the year 2012, what is the difference between the Revenue generated (in %) of Macao and Revenue generated (in %) of St. Lucia?
Provide a succinct answer. -23.84. What is the ratio of the Revenue generated (in %) of Egypt, Arab Rep. in 2005 to that in 2006?
Give a very brief answer. 0.87. What is the ratio of the Revenue generated (in %) in Macao in 2005 to that in 2006?
Offer a terse response. 0.89. What is the ratio of the Revenue generated (in %) of St. Lucia in 2005 to that in 2006?
Offer a very short reply. 1.05. What is the ratio of the Revenue generated (in %) of Latin America(developing only) in 2005 to that in 2007?
Ensure brevity in your answer.  0.97. What is the ratio of the Revenue generated (in %) of Egypt, Arab Rep. in 2005 to that in 2007?
Give a very brief answer. 0.83. What is the ratio of the Revenue generated (in %) in Macao in 2005 to that in 2007?
Give a very brief answer. 0.61. What is the ratio of the Revenue generated (in %) of St. Lucia in 2005 to that in 2007?
Ensure brevity in your answer.  0.97. What is the ratio of the Revenue generated (in %) in Latin America(developing only) in 2005 to that in 2008?
Give a very brief answer. 0.98. What is the ratio of the Revenue generated (in %) in Egypt, Arab Rep. in 2005 to that in 2008?
Ensure brevity in your answer.  0.88. What is the ratio of the Revenue generated (in %) of Macao in 2005 to that in 2008?
Ensure brevity in your answer.  0.84. What is the ratio of the Revenue generated (in %) in St. Lucia in 2005 to that in 2008?
Provide a short and direct response. 0.85. What is the ratio of the Revenue generated (in %) in Latin America(developing only) in 2005 to that in 2009?
Provide a short and direct response. 0.87. What is the ratio of the Revenue generated (in %) of Egypt, Arab Rep. in 2005 to that in 2009?
Provide a succinct answer. 0.85. What is the ratio of the Revenue generated (in %) in Macao in 2005 to that in 2009?
Your answer should be compact. 0.91. What is the ratio of the Revenue generated (in %) in St. Lucia in 2005 to that in 2009?
Make the answer very short. 0.85. What is the ratio of the Revenue generated (in %) in Latin America(developing only) in 2005 to that in 2010?
Ensure brevity in your answer.  0.95. What is the ratio of the Revenue generated (in %) in Egypt, Arab Rep. in 2005 to that in 2010?
Your answer should be very brief. 0.94. What is the ratio of the Revenue generated (in %) in Macao in 2005 to that in 2010?
Offer a terse response. 1.14. What is the ratio of the Revenue generated (in %) of St. Lucia in 2005 to that in 2010?
Give a very brief answer. 0.9. What is the ratio of the Revenue generated (in %) of Latin America(developing only) in 2005 to that in 2011?
Your response must be concise. 0.96. What is the ratio of the Revenue generated (in %) in Egypt, Arab Rep. in 2005 to that in 2011?
Offer a very short reply. 0.8. What is the ratio of the Revenue generated (in %) of Macao in 2005 to that in 2011?
Offer a terse response. 1.38. What is the ratio of the Revenue generated (in %) in St. Lucia in 2005 to that in 2011?
Give a very brief answer. 0.83. What is the ratio of the Revenue generated (in %) in Latin America(developing only) in 2005 to that in 2012?
Your response must be concise. 0.94. What is the ratio of the Revenue generated (in %) of Egypt, Arab Rep. in 2005 to that in 2012?
Make the answer very short. 0.91. What is the ratio of the Revenue generated (in %) in Macao in 2005 to that in 2012?
Ensure brevity in your answer.  1.34. What is the ratio of the Revenue generated (in %) of St. Lucia in 2005 to that in 2012?
Make the answer very short. 0.89. What is the ratio of the Revenue generated (in %) of Latin America(developing only) in 2006 to that in 2007?
Your response must be concise. 0.98. What is the ratio of the Revenue generated (in %) in Egypt, Arab Rep. in 2006 to that in 2007?
Your response must be concise. 0.96. What is the ratio of the Revenue generated (in %) of Macao in 2006 to that in 2007?
Offer a terse response. 0.68. What is the ratio of the Revenue generated (in %) of St. Lucia in 2006 to that in 2007?
Provide a succinct answer. 0.92. What is the ratio of the Revenue generated (in %) of Latin America(developing only) in 2006 to that in 2008?
Offer a very short reply. 0.99. What is the ratio of the Revenue generated (in %) of Egypt, Arab Rep. in 2006 to that in 2008?
Give a very brief answer. 1.02. What is the ratio of the Revenue generated (in %) in Macao in 2006 to that in 2008?
Offer a terse response. 0.95. What is the ratio of the Revenue generated (in %) in St. Lucia in 2006 to that in 2008?
Your response must be concise. 0.81. What is the ratio of the Revenue generated (in %) of Latin America(developing only) in 2006 to that in 2009?
Offer a terse response. 0.88. What is the ratio of the Revenue generated (in %) of Egypt, Arab Rep. in 2006 to that in 2009?
Give a very brief answer. 0.99. What is the ratio of the Revenue generated (in %) in Macao in 2006 to that in 2009?
Provide a short and direct response. 1.02. What is the ratio of the Revenue generated (in %) of St. Lucia in 2006 to that in 2009?
Offer a very short reply. 0.8. What is the ratio of the Revenue generated (in %) of Latin America(developing only) in 2006 to that in 2010?
Offer a terse response. 0.96. What is the ratio of the Revenue generated (in %) of Egypt, Arab Rep. in 2006 to that in 2010?
Offer a very short reply. 1.09. What is the ratio of the Revenue generated (in %) of Macao in 2006 to that in 2010?
Offer a very short reply. 1.28. What is the ratio of the Revenue generated (in %) of St. Lucia in 2006 to that in 2010?
Your answer should be compact. 0.86. What is the ratio of the Revenue generated (in %) in Latin America(developing only) in 2006 to that in 2011?
Offer a terse response. 0.97. What is the ratio of the Revenue generated (in %) of Egypt, Arab Rep. in 2006 to that in 2011?
Keep it short and to the point. 0.92. What is the ratio of the Revenue generated (in %) of Macao in 2006 to that in 2011?
Offer a very short reply. 1.56. What is the ratio of the Revenue generated (in %) in St. Lucia in 2006 to that in 2011?
Provide a short and direct response. 0.79. What is the ratio of the Revenue generated (in %) of Latin America(developing only) in 2006 to that in 2012?
Your response must be concise. 0.95. What is the ratio of the Revenue generated (in %) in Egypt, Arab Rep. in 2006 to that in 2012?
Make the answer very short. 1.05. What is the ratio of the Revenue generated (in %) of Macao in 2006 to that in 2012?
Offer a very short reply. 1.51. What is the ratio of the Revenue generated (in %) in St. Lucia in 2006 to that in 2012?
Offer a very short reply. 0.84. What is the ratio of the Revenue generated (in %) of Latin America(developing only) in 2007 to that in 2008?
Give a very brief answer. 1.01. What is the ratio of the Revenue generated (in %) in Egypt, Arab Rep. in 2007 to that in 2008?
Your answer should be very brief. 1.06. What is the ratio of the Revenue generated (in %) of Macao in 2007 to that in 2008?
Provide a short and direct response. 1.38. What is the ratio of the Revenue generated (in %) in St. Lucia in 2007 to that in 2008?
Your answer should be compact. 0.88. What is the ratio of the Revenue generated (in %) of Latin America(developing only) in 2007 to that in 2009?
Make the answer very short. 0.9. What is the ratio of the Revenue generated (in %) of Egypt, Arab Rep. in 2007 to that in 2009?
Your answer should be very brief. 1.02. What is the ratio of the Revenue generated (in %) in Macao in 2007 to that in 2009?
Keep it short and to the point. 1.5. What is the ratio of the Revenue generated (in %) of St. Lucia in 2007 to that in 2009?
Offer a terse response. 0.87. What is the ratio of the Revenue generated (in %) in Latin America(developing only) in 2007 to that in 2010?
Ensure brevity in your answer.  0.98. What is the ratio of the Revenue generated (in %) of Egypt, Arab Rep. in 2007 to that in 2010?
Provide a succinct answer. 1.13. What is the ratio of the Revenue generated (in %) in Macao in 2007 to that in 2010?
Keep it short and to the point. 1.87. What is the ratio of the Revenue generated (in %) of St. Lucia in 2007 to that in 2010?
Offer a terse response. 0.93. What is the ratio of the Revenue generated (in %) in Latin America(developing only) in 2007 to that in 2011?
Provide a succinct answer. 0.99. What is the ratio of the Revenue generated (in %) of Egypt, Arab Rep. in 2007 to that in 2011?
Offer a very short reply. 0.96. What is the ratio of the Revenue generated (in %) of Macao in 2007 to that in 2011?
Keep it short and to the point. 2.28. What is the ratio of the Revenue generated (in %) in St. Lucia in 2007 to that in 2011?
Your response must be concise. 0.86. What is the ratio of the Revenue generated (in %) of Latin America(developing only) in 2007 to that in 2012?
Offer a terse response. 0.97. What is the ratio of the Revenue generated (in %) of Egypt, Arab Rep. in 2007 to that in 2012?
Give a very brief answer. 1.09. What is the ratio of the Revenue generated (in %) of Macao in 2007 to that in 2012?
Your answer should be very brief. 2.21. What is the ratio of the Revenue generated (in %) of St. Lucia in 2007 to that in 2012?
Make the answer very short. 0.91. What is the ratio of the Revenue generated (in %) of Latin America(developing only) in 2008 to that in 2009?
Make the answer very short. 0.89. What is the ratio of the Revenue generated (in %) in Egypt, Arab Rep. in 2008 to that in 2009?
Keep it short and to the point. 0.97. What is the ratio of the Revenue generated (in %) in Macao in 2008 to that in 2009?
Provide a short and direct response. 1.08. What is the ratio of the Revenue generated (in %) in St. Lucia in 2008 to that in 2009?
Your answer should be very brief. 0.99. What is the ratio of the Revenue generated (in %) in Latin America(developing only) in 2008 to that in 2010?
Provide a short and direct response. 0.97. What is the ratio of the Revenue generated (in %) of Egypt, Arab Rep. in 2008 to that in 2010?
Offer a terse response. 1.07. What is the ratio of the Revenue generated (in %) in Macao in 2008 to that in 2010?
Your response must be concise. 1.35. What is the ratio of the Revenue generated (in %) in St. Lucia in 2008 to that in 2010?
Make the answer very short. 1.06. What is the ratio of the Revenue generated (in %) of Latin America(developing only) in 2008 to that in 2011?
Your answer should be compact. 0.98. What is the ratio of the Revenue generated (in %) of Egypt, Arab Rep. in 2008 to that in 2011?
Your answer should be compact. 0.91. What is the ratio of the Revenue generated (in %) of Macao in 2008 to that in 2011?
Keep it short and to the point. 1.64. What is the ratio of the Revenue generated (in %) in St. Lucia in 2008 to that in 2011?
Your response must be concise. 0.98. What is the ratio of the Revenue generated (in %) of Latin America(developing only) in 2008 to that in 2012?
Provide a short and direct response. 0.96. What is the ratio of the Revenue generated (in %) of Egypt, Arab Rep. in 2008 to that in 2012?
Provide a succinct answer. 1.03. What is the ratio of the Revenue generated (in %) in Macao in 2008 to that in 2012?
Your response must be concise. 1.6. What is the ratio of the Revenue generated (in %) in St. Lucia in 2008 to that in 2012?
Your answer should be very brief. 1.04. What is the ratio of the Revenue generated (in %) in Latin America(developing only) in 2009 to that in 2010?
Ensure brevity in your answer.  1.09. What is the ratio of the Revenue generated (in %) of Egypt, Arab Rep. in 2009 to that in 2010?
Keep it short and to the point. 1.1. What is the ratio of the Revenue generated (in %) of Macao in 2009 to that in 2010?
Provide a succinct answer. 1.25. What is the ratio of the Revenue generated (in %) of St. Lucia in 2009 to that in 2010?
Your answer should be very brief. 1.07. What is the ratio of the Revenue generated (in %) of Latin America(developing only) in 2009 to that in 2011?
Your answer should be very brief. 1.1. What is the ratio of the Revenue generated (in %) of Egypt, Arab Rep. in 2009 to that in 2011?
Provide a short and direct response. 0.94. What is the ratio of the Revenue generated (in %) of Macao in 2009 to that in 2011?
Ensure brevity in your answer.  1.52. What is the ratio of the Revenue generated (in %) of Latin America(developing only) in 2009 to that in 2012?
Ensure brevity in your answer.  1.08. What is the ratio of the Revenue generated (in %) in Egypt, Arab Rep. in 2009 to that in 2012?
Give a very brief answer. 1.06. What is the ratio of the Revenue generated (in %) in Macao in 2009 to that in 2012?
Provide a succinct answer. 1.48. What is the ratio of the Revenue generated (in %) of St. Lucia in 2009 to that in 2012?
Provide a succinct answer. 1.05. What is the ratio of the Revenue generated (in %) of Latin America(developing only) in 2010 to that in 2011?
Provide a succinct answer. 1. What is the ratio of the Revenue generated (in %) in Egypt, Arab Rep. in 2010 to that in 2011?
Ensure brevity in your answer.  0.85. What is the ratio of the Revenue generated (in %) in Macao in 2010 to that in 2011?
Your response must be concise. 1.22. What is the ratio of the Revenue generated (in %) in St. Lucia in 2010 to that in 2011?
Offer a very short reply. 0.92. What is the ratio of the Revenue generated (in %) of Latin America(developing only) in 2010 to that in 2012?
Keep it short and to the point. 0.98. What is the ratio of the Revenue generated (in %) in Egypt, Arab Rep. in 2010 to that in 2012?
Your answer should be very brief. 0.97. What is the ratio of the Revenue generated (in %) of Macao in 2010 to that in 2012?
Offer a very short reply. 1.18. What is the ratio of the Revenue generated (in %) of St. Lucia in 2010 to that in 2012?
Your answer should be very brief. 0.98. What is the ratio of the Revenue generated (in %) in Latin America(developing only) in 2011 to that in 2012?
Your answer should be very brief. 0.98. What is the ratio of the Revenue generated (in %) in Egypt, Arab Rep. in 2011 to that in 2012?
Your answer should be compact. 1.13. What is the ratio of the Revenue generated (in %) in Macao in 2011 to that in 2012?
Give a very brief answer. 0.97. What is the ratio of the Revenue generated (in %) of St. Lucia in 2011 to that in 2012?
Ensure brevity in your answer.  1.06. What is the difference between the highest and the second highest Revenue generated (in %) of Latin America(developing only)?
Make the answer very short. 1.93. What is the difference between the highest and the second highest Revenue generated (in %) of Egypt, Arab Rep.?
Ensure brevity in your answer.  1.2. What is the difference between the highest and the second highest Revenue generated (in %) in Macao?
Offer a very short reply. 2.02. What is the difference between the highest and the second highest Revenue generated (in %) in St. Lucia?
Provide a short and direct response. 0.4. What is the difference between the highest and the lowest Revenue generated (in %) of Latin America(developing only)?
Ensure brevity in your answer.  3.49. What is the difference between the highest and the lowest Revenue generated (in %) in Egypt, Arab Rep.?
Provide a short and direct response. 5.91. What is the difference between the highest and the lowest Revenue generated (in %) in Macao?
Your answer should be very brief. 4.08. What is the difference between the highest and the lowest Revenue generated (in %) in St. Lucia?
Provide a short and direct response. 6.01. 